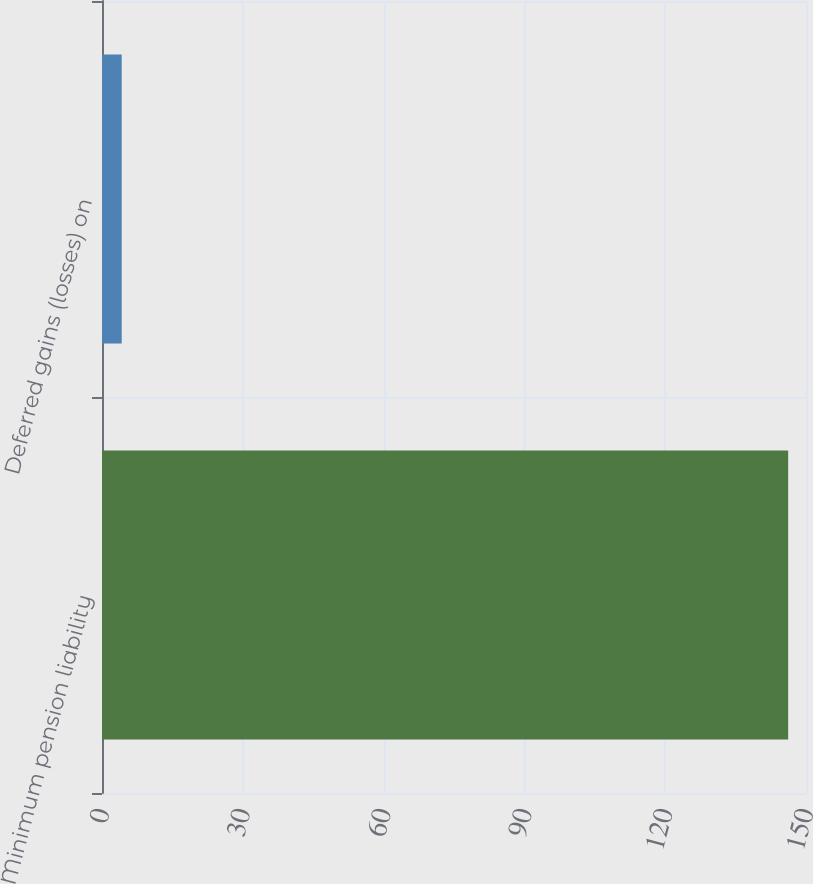Convert chart to OTSL. <chart><loc_0><loc_0><loc_500><loc_500><bar_chart><fcel>Minimum pension liability<fcel>Deferred gains (losses) on<nl><fcel>146.2<fcel>4.2<nl></chart> 